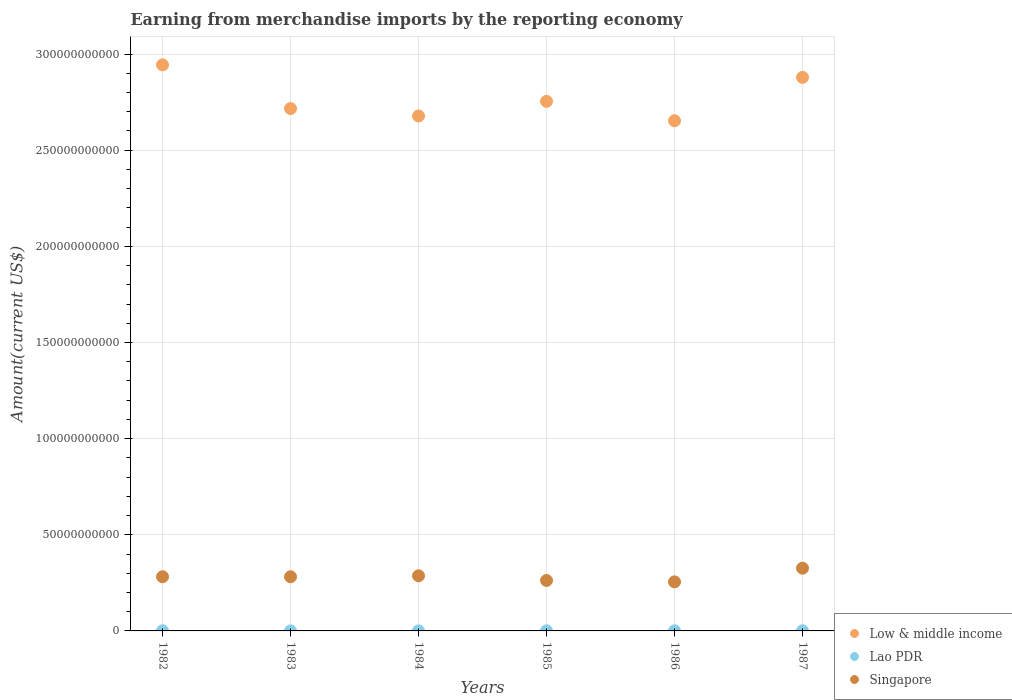Is the number of dotlines equal to the number of legend labels?
Keep it short and to the point. Yes. What is the amount earned from merchandise imports in Singapore in 1983?
Provide a short and direct response. 2.82e+1. Across all years, what is the maximum amount earned from merchandise imports in Lao PDR?
Keep it short and to the point. 7.98e+07. Across all years, what is the minimum amount earned from merchandise imports in Lao PDR?
Your answer should be very brief. 2.61e+07. In which year was the amount earned from merchandise imports in Lao PDR maximum?
Your answer should be compact. 1987. What is the total amount earned from merchandise imports in Singapore in the graph?
Keep it short and to the point. 1.69e+11. What is the difference between the amount earned from merchandise imports in Singapore in 1983 and that in 1984?
Provide a succinct answer. -5.07e+08. What is the difference between the amount earned from merchandise imports in Low & middle income in 1984 and the amount earned from merchandise imports in Singapore in 1986?
Your answer should be very brief. 2.42e+11. What is the average amount earned from merchandise imports in Low & middle income per year?
Offer a very short reply. 2.77e+11. In the year 1986, what is the difference between the amount earned from merchandise imports in Lao PDR and amount earned from merchandise imports in Singapore?
Offer a very short reply. -2.55e+1. What is the ratio of the amount earned from merchandise imports in Low & middle income in 1982 to that in 1984?
Provide a short and direct response. 1.1. Is the difference between the amount earned from merchandise imports in Lao PDR in 1984 and 1985 greater than the difference between the amount earned from merchandise imports in Singapore in 1984 and 1985?
Offer a very short reply. No. What is the difference between the highest and the second highest amount earned from merchandise imports in Low & middle income?
Ensure brevity in your answer.  6.49e+09. What is the difference between the highest and the lowest amount earned from merchandise imports in Low & middle income?
Offer a very short reply. 2.91e+1. Is the amount earned from merchandise imports in Lao PDR strictly greater than the amount earned from merchandise imports in Low & middle income over the years?
Your response must be concise. No. How many dotlines are there?
Offer a terse response. 3. How many years are there in the graph?
Provide a short and direct response. 6. What is the difference between two consecutive major ticks on the Y-axis?
Provide a short and direct response. 5.00e+1. Does the graph contain grids?
Keep it short and to the point. Yes. How many legend labels are there?
Offer a terse response. 3. How are the legend labels stacked?
Your response must be concise. Vertical. What is the title of the graph?
Your answer should be very brief. Earning from merchandise imports by the reporting economy. Does "Marshall Islands" appear as one of the legend labels in the graph?
Make the answer very short. No. What is the label or title of the X-axis?
Provide a short and direct response. Years. What is the label or title of the Y-axis?
Your response must be concise. Amount(current US$). What is the Amount(current US$) in Low & middle income in 1982?
Provide a succinct answer. 2.94e+11. What is the Amount(current US$) of Lao PDR in 1982?
Keep it short and to the point. 7.61e+07. What is the Amount(current US$) in Singapore in 1982?
Make the answer very short. 2.82e+1. What is the Amount(current US$) of Low & middle income in 1983?
Offer a very short reply. 2.72e+11. What is the Amount(current US$) in Lao PDR in 1983?
Your answer should be compact. 2.61e+07. What is the Amount(current US$) of Singapore in 1983?
Give a very brief answer. 2.82e+1. What is the Amount(current US$) of Low & middle income in 1984?
Your answer should be compact. 2.68e+11. What is the Amount(current US$) in Lao PDR in 1984?
Your answer should be compact. 4.05e+07. What is the Amount(current US$) of Singapore in 1984?
Give a very brief answer. 2.87e+1. What is the Amount(current US$) in Low & middle income in 1985?
Your answer should be compact. 2.75e+11. What is the Amount(current US$) in Lao PDR in 1985?
Ensure brevity in your answer.  5.40e+07. What is the Amount(current US$) in Singapore in 1985?
Make the answer very short. 2.62e+1. What is the Amount(current US$) in Low & middle income in 1986?
Your response must be concise. 2.65e+11. What is the Amount(current US$) in Lao PDR in 1986?
Provide a succinct answer. 6.01e+07. What is the Amount(current US$) in Singapore in 1986?
Provide a short and direct response. 2.55e+1. What is the Amount(current US$) of Low & middle income in 1987?
Your answer should be compact. 2.88e+11. What is the Amount(current US$) in Lao PDR in 1987?
Ensure brevity in your answer.  7.98e+07. What is the Amount(current US$) of Singapore in 1987?
Your response must be concise. 3.26e+1. Across all years, what is the maximum Amount(current US$) in Low & middle income?
Your response must be concise. 2.94e+11. Across all years, what is the maximum Amount(current US$) in Lao PDR?
Provide a short and direct response. 7.98e+07. Across all years, what is the maximum Amount(current US$) in Singapore?
Provide a short and direct response. 3.26e+1. Across all years, what is the minimum Amount(current US$) in Low & middle income?
Provide a short and direct response. 2.65e+11. Across all years, what is the minimum Amount(current US$) of Lao PDR?
Give a very brief answer. 2.61e+07. Across all years, what is the minimum Amount(current US$) of Singapore?
Ensure brevity in your answer.  2.55e+1. What is the total Amount(current US$) of Low & middle income in the graph?
Offer a very short reply. 1.66e+12. What is the total Amount(current US$) in Lao PDR in the graph?
Offer a very short reply. 3.37e+08. What is the total Amount(current US$) in Singapore in the graph?
Offer a terse response. 1.69e+11. What is the difference between the Amount(current US$) in Low & middle income in 1982 and that in 1983?
Make the answer very short. 2.27e+1. What is the difference between the Amount(current US$) of Lao PDR in 1982 and that in 1983?
Your response must be concise. 5.00e+07. What is the difference between the Amount(current US$) in Singapore in 1982 and that in 1983?
Provide a succinct answer. 1.52e+07. What is the difference between the Amount(current US$) of Low & middle income in 1982 and that in 1984?
Make the answer very short. 2.66e+1. What is the difference between the Amount(current US$) of Lao PDR in 1982 and that in 1984?
Provide a succinct answer. 3.56e+07. What is the difference between the Amount(current US$) of Singapore in 1982 and that in 1984?
Offer a terse response. -4.92e+08. What is the difference between the Amount(current US$) of Low & middle income in 1982 and that in 1985?
Make the answer very short. 1.90e+1. What is the difference between the Amount(current US$) in Lao PDR in 1982 and that in 1985?
Your answer should be compact. 2.21e+07. What is the difference between the Amount(current US$) in Singapore in 1982 and that in 1985?
Keep it short and to the point. 1.94e+09. What is the difference between the Amount(current US$) of Low & middle income in 1982 and that in 1986?
Ensure brevity in your answer.  2.91e+1. What is the difference between the Amount(current US$) of Lao PDR in 1982 and that in 1986?
Keep it short and to the point. 1.60e+07. What is the difference between the Amount(current US$) in Singapore in 1982 and that in 1986?
Ensure brevity in your answer.  2.67e+09. What is the difference between the Amount(current US$) in Low & middle income in 1982 and that in 1987?
Ensure brevity in your answer.  6.49e+09. What is the difference between the Amount(current US$) of Lao PDR in 1982 and that in 1987?
Offer a terse response. -3.72e+06. What is the difference between the Amount(current US$) of Singapore in 1982 and that in 1987?
Provide a short and direct response. -4.45e+09. What is the difference between the Amount(current US$) of Low & middle income in 1983 and that in 1984?
Give a very brief answer. 3.85e+09. What is the difference between the Amount(current US$) in Lao PDR in 1983 and that in 1984?
Your answer should be compact. -1.44e+07. What is the difference between the Amount(current US$) in Singapore in 1983 and that in 1984?
Offer a very short reply. -5.07e+08. What is the difference between the Amount(current US$) of Low & middle income in 1983 and that in 1985?
Keep it short and to the point. -3.76e+09. What is the difference between the Amount(current US$) of Lao PDR in 1983 and that in 1985?
Keep it short and to the point. -2.79e+07. What is the difference between the Amount(current US$) in Singapore in 1983 and that in 1985?
Your answer should be very brief. 1.93e+09. What is the difference between the Amount(current US$) of Low & middle income in 1983 and that in 1986?
Make the answer very short. 6.33e+09. What is the difference between the Amount(current US$) of Lao PDR in 1983 and that in 1986?
Give a very brief answer. -3.40e+07. What is the difference between the Amount(current US$) in Singapore in 1983 and that in 1986?
Provide a short and direct response. 2.65e+09. What is the difference between the Amount(current US$) in Low & middle income in 1983 and that in 1987?
Your answer should be compact. -1.62e+1. What is the difference between the Amount(current US$) of Lao PDR in 1983 and that in 1987?
Provide a short and direct response. -5.37e+07. What is the difference between the Amount(current US$) in Singapore in 1983 and that in 1987?
Make the answer very short. -4.46e+09. What is the difference between the Amount(current US$) in Low & middle income in 1984 and that in 1985?
Your answer should be compact. -7.62e+09. What is the difference between the Amount(current US$) in Lao PDR in 1984 and that in 1985?
Provide a succinct answer. -1.35e+07. What is the difference between the Amount(current US$) in Singapore in 1984 and that in 1985?
Give a very brief answer. 2.43e+09. What is the difference between the Amount(current US$) of Low & middle income in 1984 and that in 1986?
Offer a very short reply. 2.48e+09. What is the difference between the Amount(current US$) of Lao PDR in 1984 and that in 1986?
Keep it short and to the point. -1.96e+07. What is the difference between the Amount(current US$) in Singapore in 1984 and that in 1986?
Provide a short and direct response. 3.16e+09. What is the difference between the Amount(current US$) in Low & middle income in 1984 and that in 1987?
Your answer should be very brief. -2.01e+1. What is the difference between the Amount(current US$) of Lao PDR in 1984 and that in 1987?
Offer a terse response. -3.93e+07. What is the difference between the Amount(current US$) of Singapore in 1984 and that in 1987?
Offer a very short reply. -3.96e+09. What is the difference between the Amount(current US$) in Low & middle income in 1985 and that in 1986?
Your answer should be very brief. 1.01e+1. What is the difference between the Amount(current US$) in Lao PDR in 1985 and that in 1986?
Provide a short and direct response. -6.09e+06. What is the difference between the Amount(current US$) in Singapore in 1985 and that in 1986?
Make the answer very short. 7.25e+08. What is the difference between the Amount(current US$) in Low & middle income in 1985 and that in 1987?
Give a very brief answer. -1.25e+1. What is the difference between the Amount(current US$) of Lao PDR in 1985 and that in 1987?
Your answer should be compact. -2.58e+07. What is the difference between the Amount(current US$) of Singapore in 1985 and that in 1987?
Ensure brevity in your answer.  -6.39e+09. What is the difference between the Amount(current US$) in Low & middle income in 1986 and that in 1987?
Provide a short and direct response. -2.26e+1. What is the difference between the Amount(current US$) of Lao PDR in 1986 and that in 1987?
Give a very brief answer. -1.97e+07. What is the difference between the Amount(current US$) of Singapore in 1986 and that in 1987?
Give a very brief answer. -7.11e+09. What is the difference between the Amount(current US$) of Low & middle income in 1982 and the Amount(current US$) of Lao PDR in 1983?
Provide a succinct answer. 2.94e+11. What is the difference between the Amount(current US$) of Low & middle income in 1982 and the Amount(current US$) of Singapore in 1983?
Your answer should be compact. 2.66e+11. What is the difference between the Amount(current US$) in Lao PDR in 1982 and the Amount(current US$) in Singapore in 1983?
Ensure brevity in your answer.  -2.81e+1. What is the difference between the Amount(current US$) in Low & middle income in 1982 and the Amount(current US$) in Lao PDR in 1984?
Ensure brevity in your answer.  2.94e+11. What is the difference between the Amount(current US$) in Low & middle income in 1982 and the Amount(current US$) in Singapore in 1984?
Give a very brief answer. 2.66e+11. What is the difference between the Amount(current US$) of Lao PDR in 1982 and the Amount(current US$) of Singapore in 1984?
Ensure brevity in your answer.  -2.86e+1. What is the difference between the Amount(current US$) of Low & middle income in 1982 and the Amount(current US$) of Lao PDR in 1985?
Ensure brevity in your answer.  2.94e+11. What is the difference between the Amount(current US$) in Low & middle income in 1982 and the Amount(current US$) in Singapore in 1985?
Your answer should be very brief. 2.68e+11. What is the difference between the Amount(current US$) of Lao PDR in 1982 and the Amount(current US$) of Singapore in 1985?
Keep it short and to the point. -2.62e+1. What is the difference between the Amount(current US$) of Low & middle income in 1982 and the Amount(current US$) of Lao PDR in 1986?
Make the answer very short. 2.94e+11. What is the difference between the Amount(current US$) in Low & middle income in 1982 and the Amount(current US$) in Singapore in 1986?
Give a very brief answer. 2.69e+11. What is the difference between the Amount(current US$) of Lao PDR in 1982 and the Amount(current US$) of Singapore in 1986?
Keep it short and to the point. -2.54e+1. What is the difference between the Amount(current US$) in Low & middle income in 1982 and the Amount(current US$) in Lao PDR in 1987?
Give a very brief answer. 2.94e+11. What is the difference between the Amount(current US$) in Low & middle income in 1982 and the Amount(current US$) in Singapore in 1987?
Make the answer very short. 2.62e+11. What is the difference between the Amount(current US$) of Lao PDR in 1982 and the Amount(current US$) of Singapore in 1987?
Provide a succinct answer. -3.26e+1. What is the difference between the Amount(current US$) of Low & middle income in 1983 and the Amount(current US$) of Lao PDR in 1984?
Make the answer very short. 2.72e+11. What is the difference between the Amount(current US$) of Low & middle income in 1983 and the Amount(current US$) of Singapore in 1984?
Make the answer very short. 2.43e+11. What is the difference between the Amount(current US$) in Lao PDR in 1983 and the Amount(current US$) in Singapore in 1984?
Offer a very short reply. -2.86e+1. What is the difference between the Amount(current US$) of Low & middle income in 1983 and the Amount(current US$) of Lao PDR in 1985?
Offer a terse response. 2.72e+11. What is the difference between the Amount(current US$) of Low & middle income in 1983 and the Amount(current US$) of Singapore in 1985?
Provide a succinct answer. 2.45e+11. What is the difference between the Amount(current US$) of Lao PDR in 1983 and the Amount(current US$) of Singapore in 1985?
Your answer should be compact. -2.62e+1. What is the difference between the Amount(current US$) of Low & middle income in 1983 and the Amount(current US$) of Lao PDR in 1986?
Provide a short and direct response. 2.72e+11. What is the difference between the Amount(current US$) of Low & middle income in 1983 and the Amount(current US$) of Singapore in 1986?
Ensure brevity in your answer.  2.46e+11. What is the difference between the Amount(current US$) of Lao PDR in 1983 and the Amount(current US$) of Singapore in 1986?
Ensure brevity in your answer.  -2.55e+1. What is the difference between the Amount(current US$) in Low & middle income in 1983 and the Amount(current US$) in Lao PDR in 1987?
Give a very brief answer. 2.72e+11. What is the difference between the Amount(current US$) of Low & middle income in 1983 and the Amount(current US$) of Singapore in 1987?
Provide a succinct answer. 2.39e+11. What is the difference between the Amount(current US$) in Lao PDR in 1983 and the Amount(current US$) in Singapore in 1987?
Ensure brevity in your answer.  -3.26e+1. What is the difference between the Amount(current US$) of Low & middle income in 1984 and the Amount(current US$) of Lao PDR in 1985?
Offer a very short reply. 2.68e+11. What is the difference between the Amount(current US$) of Low & middle income in 1984 and the Amount(current US$) of Singapore in 1985?
Give a very brief answer. 2.42e+11. What is the difference between the Amount(current US$) of Lao PDR in 1984 and the Amount(current US$) of Singapore in 1985?
Your answer should be very brief. -2.62e+1. What is the difference between the Amount(current US$) in Low & middle income in 1984 and the Amount(current US$) in Lao PDR in 1986?
Offer a terse response. 2.68e+11. What is the difference between the Amount(current US$) in Low & middle income in 1984 and the Amount(current US$) in Singapore in 1986?
Keep it short and to the point. 2.42e+11. What is the difference between the Amount(current US$) in Lao PDR in 1984 and the Amount(current US$) in Singapore in 1986?
Offer a terse response. -2.55e+1. What is the difference between the Amount(current US$) of Low & middle income in 1984 and the Amount(current US$) of Lao PDR in 1987?
Ensure brevity in your answer.  2.68e+11. What is the difference between the Amount(current US$) in Low & middle income in 1984 and the Amount(current US$) in Singapore in 1987?
Offer a terse response. 2.35e+11. What is the difference between the Amount(current US$) in Lao PDR in 1984 and the Amount(current US$) in Singapore in 1987?
Provide a succinct answer. -3.26e+1. What is the difference between the Amount(current US$) of Low & middle income in 1985 and the Amount(current US$) of Lao PDR in 1986?
Keep it short and to the point. 2.75e+11. What is the difference between the Amount(current US$) in Low & middle income in 1985 and the Amount(current US$) in Singapore in 1986?
Keep it short and to the point. 2.50e+11. What is the difference between the Amount(current US$) of Lao PDR in 1985 and the Amount(current US$) of Singapore in 1986?
Your answer should be compact. -2.55e+1. What is the difference between the Amount(current US$) of Low & middle income in 1985 and the Amount(current US$) of Lao PDR in 1987?
Give a very brief answer. 2.75e+11. What is the difference between the Amount(current US$) of Low & middle income in 1985 and the Amount(current US$) of Singapore in 1987?
Make the answer very short. 2.43e+11. What is the difference between the Amount(current US$) of Lao PDR in 1985 and the Amount(current US$) of Singapore in 1987?
Keep it short and to the point. -3.26e+1. What is the difference between the Amount(current US$) in Low & middle income in 1986 and the Amount(current US$) in Lao PDR in 1987?
Ensure brevity in your answer.  2.65e+11. What is the difference between the Amount(current US$) in Low & middle income in 1986 and the Amount(current US$) in Singapore in 1987?
Your answer should be very brief. 2.33e+11. What is the difference between the Amount(current US$) of Lao PDR in 1986 and the Amount(current US$) of Singapore in 1987?
Give a very brief answer. -3.26e+1. What is the average Amount(current US$) in Low & middle income per year?
Your answer should be compact. 2.77e+11. What is the average Amount(current US$) in Lao PDR per year?
Offer a terse response. 5.61e+07. What is the average Amount(current US$) of Singapore per year?
Your answer should be very brief. 2.82e+1. In the year 1982, what is the difference between the Amount(current US$) of Low & middle income and Amount(current US$) of Lao PDR?
Your answer should be very brief. 2.94e+11. In the year 1982, what is the difference between the Amount(current US$) in Low & middle income and Amount(current US$) in Singapore?
Ensure brevity in your answer.  2.66e+11. In the year 1982, what is the difference between the Amount(current US$) in Lao PDR and Amount(current US$) in Singapore?
Offer a very short reply. -2.81e+1. In the year 1983, what is the difference between the Amount(current US$) in Low & middle income and Amount(current US$) in Lao PDR?
Offer a terse response. 2.72e+11. In the year 1983, what is the difference between the Amount(current US$) in Low & middle income and Amount(current US$) in Singapore?
Your answer should be compact. 2.43e+11. In the year 1983, what is the difference between the Amount(current US$) in Lao PDR and Amount(current US$) in Singapore?
Your answer should be very brief. -2.81e+1. In the year 1984, what is the difference between the Amount(current US$) in Low & middle income and Amount(current US$) in Lao PDR?
Give a very brief answer. 2.68e+11. In the year 1984, what is the difference between the Amount(current US$) of Low & middle income and Amount(current US$) of Singapore?
Make the answer very short. 2.39e+11. In the year 1984, what is the difference between the Amount(current US$) of Lao PDR and Amount(current US$) of Singapore?
Keep it short and to the point. -2.86e+1. In the year 1985, what is the difference between the Amount(current US$) of Low & middle income and Amount(current US$) of Lao PDR?
Your response must be concise. 2.75e+11. In the year 1985, what is the difference between the Amount(current US$) in Low & middle income and Amount(current US$) in Singapore?
Provide a succinct answer. 2.49e+11. In the year 1985, what is the difference between the Amount(current US$) in Lao PDR and Amount(current US$) in Singapore?
Ensure brevity in your answer.  -2.62e+1. In the year 1986, what is the difference between the Amount(current US$) in Low & middle income and Amount(current US$) in Lao PDR?
Keep it short and to the point. 2.65e+11. In the year 1986, what is the difference between the Amount(current US$) of Low & middle income and Amount(current US$) of Singapore?
Offer a very short reply. 2.40e+11. In the year 1986, what is the difference between the Amount(current US$) in Lao PDR and Amount(current US$) in Singapore?
Keep it short and to the point. -2.55e+1. In the year 1987, what is the difference between the Amount(current US$) in Low & middle income and Amount(current US$) in Lao PDR?
Keep it short and to the point. 2.88e+11. In the year 1987, what is the difference between the Amount(current US$) in Low & middle income and Amount(current US$) in Singapore?
Make the answer very short. 2.55e+11. In the year 1987, what is the difference between the Amount(current US$) in Lao PDR and Amount(current US$) in Singapore?
Offer a very short reply. -3.25e+1. What is the ratio of the Amount(current US$) of Low & middle income in 1982 to that in 1983?
Offer a very short reply. 1.08. What is the ratio of the Amount(current US$) in Lao PDR in 1982 to that in 1983?
Provide a short and direct response. 2.91. What is the ratio of the Amount(current US$) of Singapore in 1982 to that in 1983?
Make the answer very short. 1. What is the ratio of the Amount(current US$) in Low & middle income in 1982 to that in 1984?
Ensure brevity in your answer.  1.1. What is the ratio of the Amount(current US$) in Lao PDR in 1982 to that in 1984?
Offer a very short reply. 1.88. What is the ratio of the Amount(current US$) in Singapore in 1982 to that in 1984?
Ensure brevity in your answer.  0.98. What is the ratio of the Amount(current US$) of Low & middle income in 1982 to that in 1985?
Your answer should be very brief. 1.07. What is the ratio of the Amount(current US$) in Lao PDR in 1982 to that in 1985?
Your answer should be compact. 1.41. What is the ratio of the Amount(current US$) in Singapore in 1982 to that in 1985?
Your answer should be very brief. 1.07. What is the ratio of the Amount(current US$) of Low & middle income in 1982 to that in 1986?
Offer a terse response. 1.11. What is the ratio of the Amount(current US$) in Lao PDR in 1982 to that in 1986?
Your response must be concise. 1.27. What is the ratio of the Amount(current US$) of Singapore in 1982 to that in 1986?
Keep it short and to the point. 1.1. What is the ratio of the Amount(current US$) in Low & middle income in 1982 to that in 1987?
Offer a very short reply. 1.02. What is the ratio of the Amount(current US$) of Lao PDR in 1982 to that in 1987?
Offer a very short reply. 0.95. What is the ratio of the Amount(current US$) in Singapore in 1982 to that in 1987?
Offer a very short reply. 0.86. What is the ratio of the Amount(current US$) of Low & middle income in 1983 to that in 1984?
Give a very brief answer. 1.01. What is the ratio of the Amount(current US$) of Lao PDR in 1983 to that in 1984?
Make the answer very short. 0.65. What is the ratio of the Amount(current US$) in Singapore in 1983 to that in 1984?
Keep it short and to the point. 0.98. What is the ratio of the Amount(current US$) of Low & middle income in 1983 to that in 1985?
Your answer should be very brief. 0.99. What is the ratio of the Amount(current US$) in Lao PDR in 1983 to that in 1985?
Your response must be concise. 0.48. What is the ratio of the Amount(current US$) in Singapore in 1983 to that in 1985?
Make the answer very short. 1.07. What is the ratio of the Amount(current US$) in Low & middle income in 1983 to that in 1986?
Offer a very short reply. 1.02. What is the ratio of the Amount(current US$) in Lao PDR in 1983 to that in 1986?
Ensure brevity in your answer.  0.43. What is the ratio of the Amount(current US$) of Singapore in 1983 to that in 1986?
Offer a terse response. 1.1. What is the ratio of the Amount(current US$) of Low & middle income in 1983 to that in 1987?
Provide a short and direct response. 0.94. What is the ratio of the Amount(current US$) in Lao PDR in 1983 to that in 1987?
Make the answer very short. 0.33. What is the ratio of the Amount(current US$) in Singapore in 1983 to that in 1987?
Make the answer very short. 0.86. What is the ratio of the Amount(current US$) in Low & middle income in 1984 to that in 1985?
Your answer should be very brief. 0.97. What is the ratio of the Amount(current US$) in Lao PDR in 1984 to that in 1985?
Keep it short and to the point. 0.75. What is the ratio of the Amount(current US$) of Singapore in 1984 to that in 1985?
Make the answer very short. 1.09. What is the ratio of the Amount(current US$) in Low & middle income in 1984 to that in 1986?
Keep it short and to the point. 1.01. What is the ratio of the Amount(current US$) in Lao PDR in 1984 to that in 1986?
Your response must be concise. 0.67. What is the ratio of the Amount(current US$) of Singapore in 1984 to that in 1986?
Provide a short and direct response. 1.12. What is the ratio of the Amount(current US$) of Low & middle income in 1984 to that in 1987?
Your response must be concise. 0.93. What is the ratio of the Amount(current US$) of Lao PDR in 1984 to that in 1987?
Give a very brief answer. 0.51. What is the ratio of the Amount(current US$) in Singapore in 1984 to that in 1987?
Make the answer very short. 0.88. What is the ratio of the Amount(current US$) of Low & middle income in 1985 to that in 1986?
Make the answer very short. 1.04. What is the ratio of the Amount(current US$) in Lao PDR in 1985 to that in 1986?
Keep it short and to the point. 0.9. What is the ratio of the Amount(current US$) in Singapore in 1985 to that in 1986?
Provide a short and direct response. 1.03. What is the ratio of the Amount(current US$) in Low & middle income in 1985 to that in 1987?
Provide a short and direct response. 0.96. What is the ratio of the Amount(current US$) of Lao PDR in 1985 to that in 1987?
Keep it short and to the point. 0.68. What is the ratio of the Amount(current US$) in Singapore in 1985 to that in 1987?
Provide a short and direct response. 0.8. What is the ratio of the Amount(current US$) in Low & middle income in 1986 to that in 1987?
Your response must be concise. 0.92. What is the ratio of the Amount(current US$) in Lao PDR in 1986 to that in 1987?
Provide a succinct answer. 0.75. What is the ratio of the Amount(current US$) of Singapore in 1986 to that in 1987?
Provide a succinct answer. 0.78. What is the difference between the highest and the second highest Amount(current US$) of Low & middle income?
Give a very brief answer. 6.49e+09. What is the difference between the highest and the second highest Amount(current US$) of Lao PDR?
Give a very brief answer. 3.72e+06. What is the difference between the highest and the second highest Amount(current US$) in Singapore?
Ensure brevity in your answer.  3.96e+09. What is the difference between the highest and the lowest Amount(current US$) in Low & middle income?
Offer a terse response. 2.91e+1. What is the difference between the highest and the lowest Amount(current US$) in Lao PDR?
Offer a very short reply. 5.37e+07. What is the difference between the highest and the lowest Amount(current US$) of Singapore?
Your answer should be compact. 7.11e+09. 